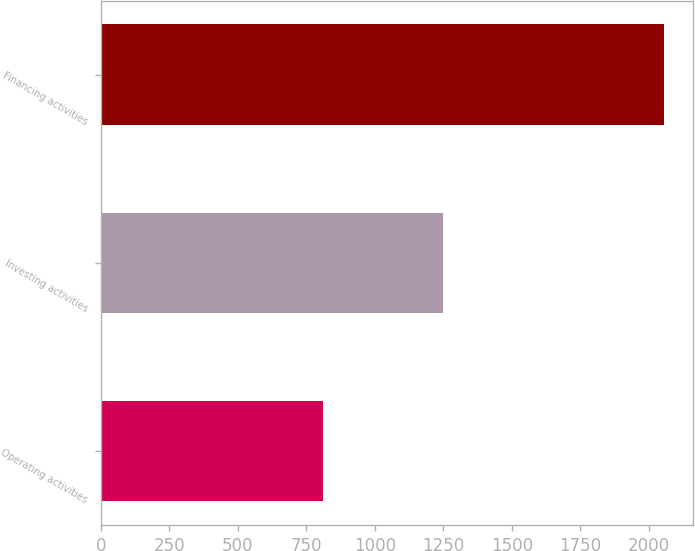Convert chart to OTSL. <chart><loc_0><loc_0><loc_500><loc_500><bar_chart><fcel>Operating activities<fcel>Investing activities<fcel>Financing activities<nl><fcel>809.9<fcel>1247.4<fcel>2057.5<nl></chart> 